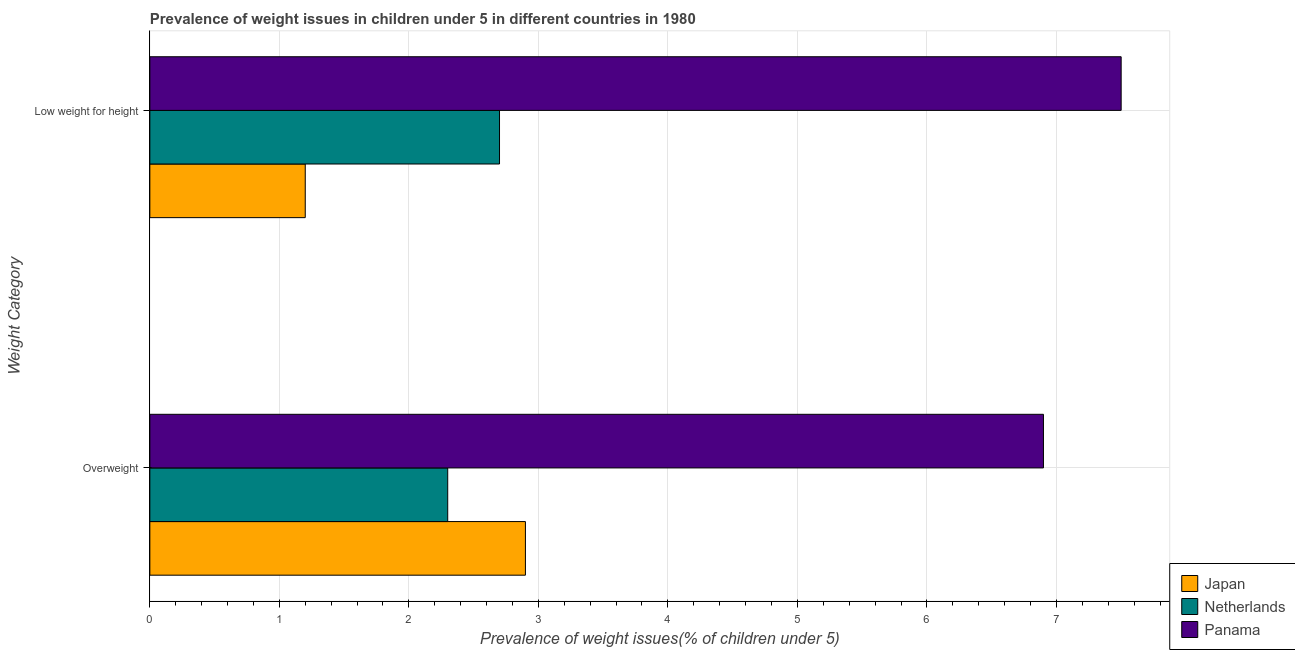How many groups of bars are there?
Ensure brevity in your answer.  2. Are the number of bars on each tick of the Y-axis equal?
Ensure brevity in your answer.  Yes. What is the label of the 2nd group of bars from the top?
Provide a short and direct response. Overweight. Across all countries, what is the minimum percentage of underweight children?
Keep it short and to the point. 1.2. In which country was the percentage of underweight children maximum?
Offer a very short reply. Panama. What is the total percentage of underweight children in the graph?
Your answer should be compact. 11.4. What is the difference between the percentage of underweight children in Japan and that in Panama?
Provide a short and direct response. -6.3. What is the difference between the percentage of overweight children in Japan and the percentage of underweight children in Panama?
Keep it short and to the point. -4.6. What is the average percentage of underweight children per country?
Offer a terse response. 3.8. What is the difference between the percentage of overweight children and percentage of underweight children in Netherlands?
Offer a terse response. -0.4. What is the ratio of the percentage of overweight children in Panama to that in Netherlands?
Provide a short and direct response. 3. Is the percentage of overweight children in Netherlands less than that in Japan?
Make the answer very short. Yes. What does the 2nd bar from the top in Overweight represents?
Give a very brief answer. Netherlands. What does the 3rd bar from the bottom in Low weight for height represents?
Your response must be concise. Panama. How many bars are there?
Give a very brief answer. 6. Are all the bars in the graph horizontal?
Keep it short and to the point. Yes. Are the values on the major ticks of X-axis written in scientific E-notation?
Give a very brief answer. No. Does the graph contain any zero values?
Keep it short and to the point. No. How many legend labels are there?
Give a very brief answer. 3. What is the title of the graph?
Give a very brief answer. Prevalence of weight issues in children under 5 in different countries in 1980. Does "French Polynesia" appear as one of the legend labels in the graph?
Your answer should be compact. No. What is the label or title of the X-axis?
Offer a very short reply. Prevalence of weight issues(% of children under 5). What is the label or title of the Y-axis?
Ensure brevity in your answer.  Weight Category. What is the Prevalence of weight issues(% of children under 5) of Japan in Overweight?
Keep it short and to the point. 2.9. What is the Prevalence of weight issues(% of children under 5) in Netherlands in Overweight?
Your answer should be very brief. 2.3. What is the Prevalence of weight issues(% of children under 5) of Panama in Overweight?
Your answer should be very brief. 6.9. What is the Prevalence of weight issues(% of children under 5) in Japan in Low weight for height?
Give a very brief answer. 1.2. What is the Prevalence of weight issues(% of children under 5) of Netherlands in Low weight for height?
Ensure brevity in your answer.  2.7. Across all Weight Category, what is the maximum Prevalence of weight issues(% of children under 5) in Japan?
Your response must be concise. 2.9. Across all Weight Category, what is the maximum Prevalence of weight issues(% of children under 5) of Netherlands?
Your answer should be compact. 2.7. Across all Weight Category, what is the minimum Prevalence of weight issues(% of children under 5) in Japan?
Provide a succinct answer. 1.2. Across all Weight Category, what is the minimum Prevalence of weight issues(% of children under 5) of Netherlands?
Make the answer very short. 2.3. Across all Weight Category, what is the minimum Prevalence of weight issues(% of children under 5) in Panama?
Keep it short and to the point. 6.9. What is the difference between the Prevalence of weight issues(% of children under 5) in Japan in Overweight and that in Low weight for height?
Offer a very short reply. 1.7. What is the difference between the Prevalence of weight issues(% of children under 5) of Panama in Overweight and that in Low weight for height?
Provide a succinct answer. -0.6. What is the difference between the Prevalence of weight issues(% of children under 5) in Japan in Overweight and the Prevalence of weight issues(% of children under 5) in Panama in Low weight for height?
Provide a short and direct response. -4.6. What is the average Prevalence of weight issues(% of children under 5) in Japan per Weight Category?
Your response must be concise. 2.05. What is the average Prevalence of weight issues(% of children under 5) of Netherlands per Weight Category?
Make the answer very short. 2.5. What is the difference between the Prevalence of weight issues(% of children under 5) in Japan and Prevalence of weight issues(% of children under 5) in Netherlands in Low weight for height?
Your response must be concise. -1.5. What is the difference between the Prevalence of weight issues(% of children under 5) of Japan and Prevalence of weight issues(% of children under 5) of Panama in Low weight for height?
Your response must be concise. -6.3. What is the ratio of the Prevalence of weight issues(% of children under 5) of Japan in Overweight to that in Low weight for height?
Offer a very short reply. 2.42. What is the ratio of the Prevalence of weight issues(% of children under 5) in Netherlands in Overweight to that in Low weight for height?
Offer a terse response. 0.85. What is the difference between the highest and the second highest Prevalence of weight issues(% of children under 5) of Netherlands?
Your answer should be very brief. 0.4. What is the difference between the highest and the second highest Prevalence of weight issues(% of children under 5) of Panama?
Make the answer very short. 0.6. What is the difference between the highest and the lowest Prevalence of weight issues(% of children under 5) of Japan?
Give a very brief answer. 1.7. What is the difference between the highest and the lowest Prevalence of weight issues(% of children under 5) in Netherlands?
Make the answer very short. 0.4. What is the difference between the highest and the lowest Prevalence of weight issues(% of children under 5) in Panama?
Keep it short and to the point. 0.6. 